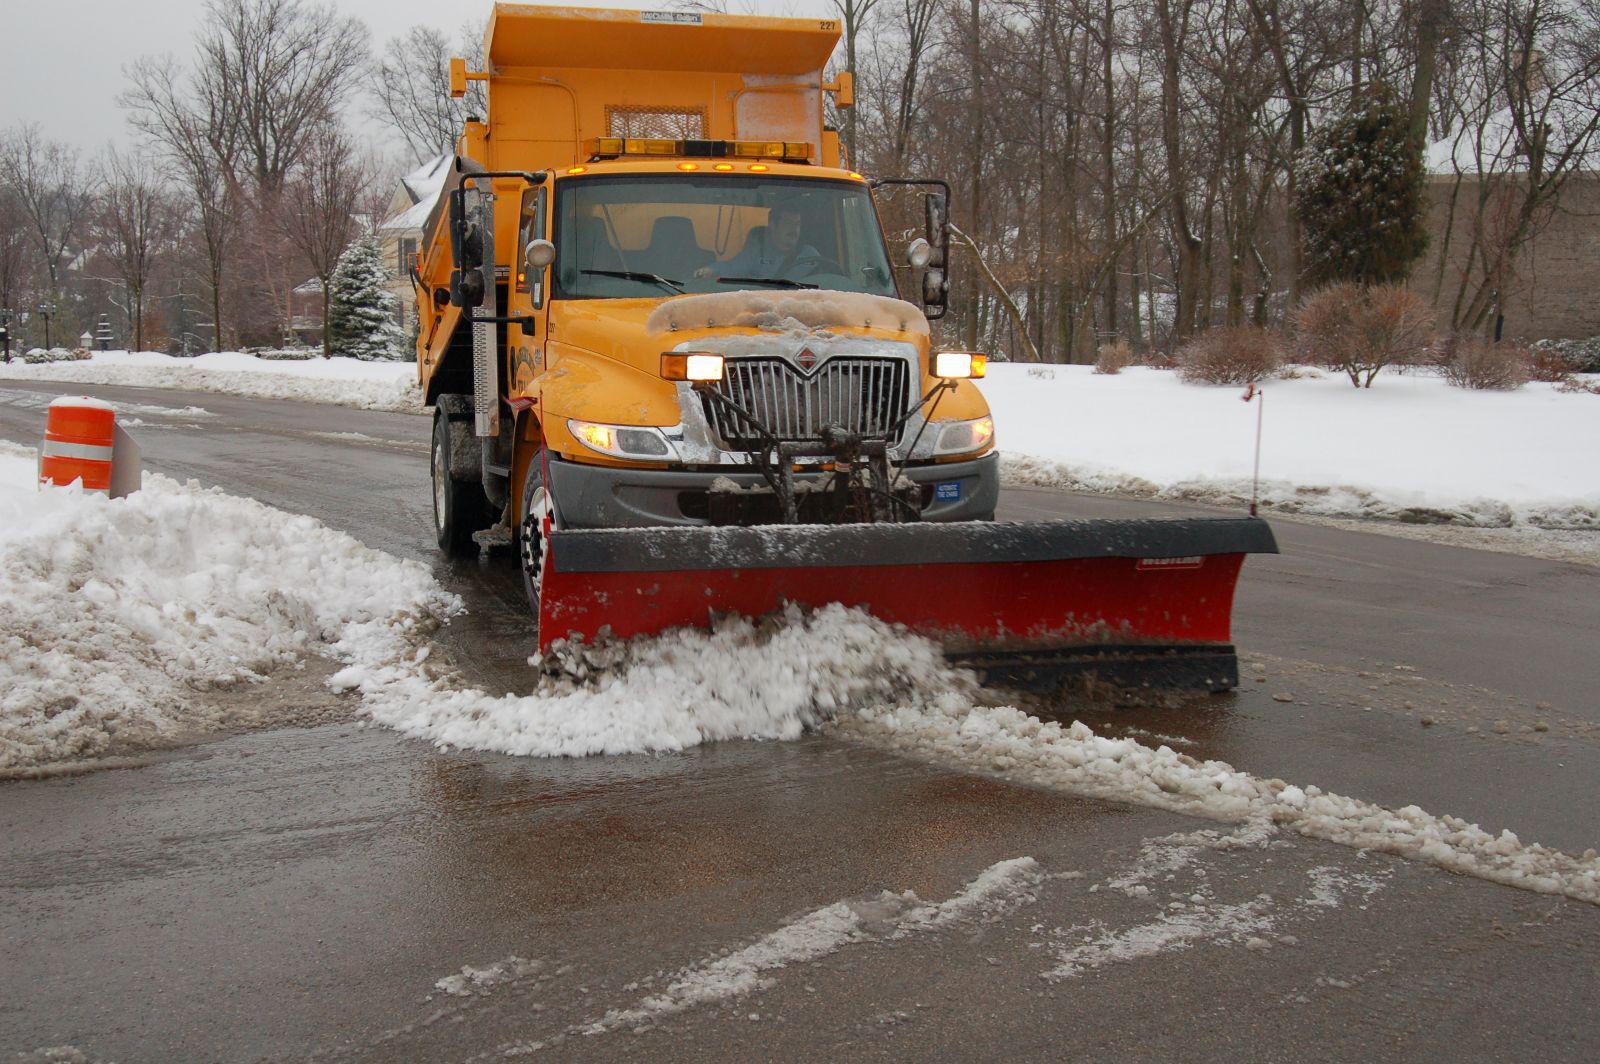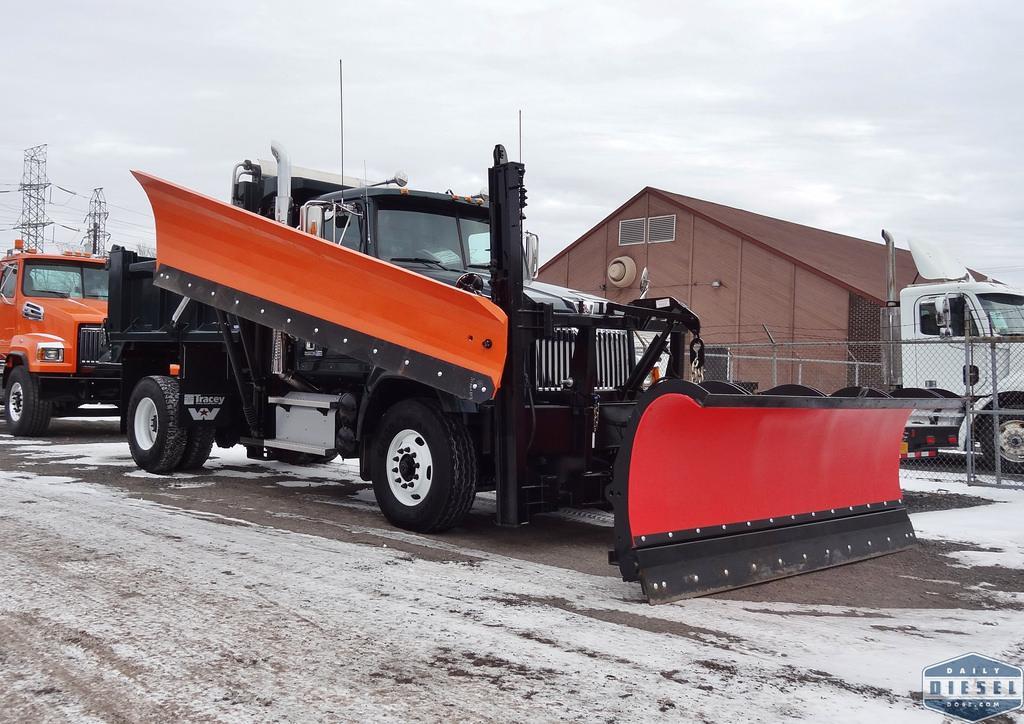The first image is the image on the left, the second image is the image on the right. Given the left and right images, does the statement "The left and right image contains the same number of orange snow trucks." hold true? Answer yes or no. No. The first image is the image on the left, the second image is the image on the right. Evaluate the accuracy of this statement regarding the images: "One snow plow is parked in a non-snow covered parking lot.". Is it true? Answer yes or no. No. 